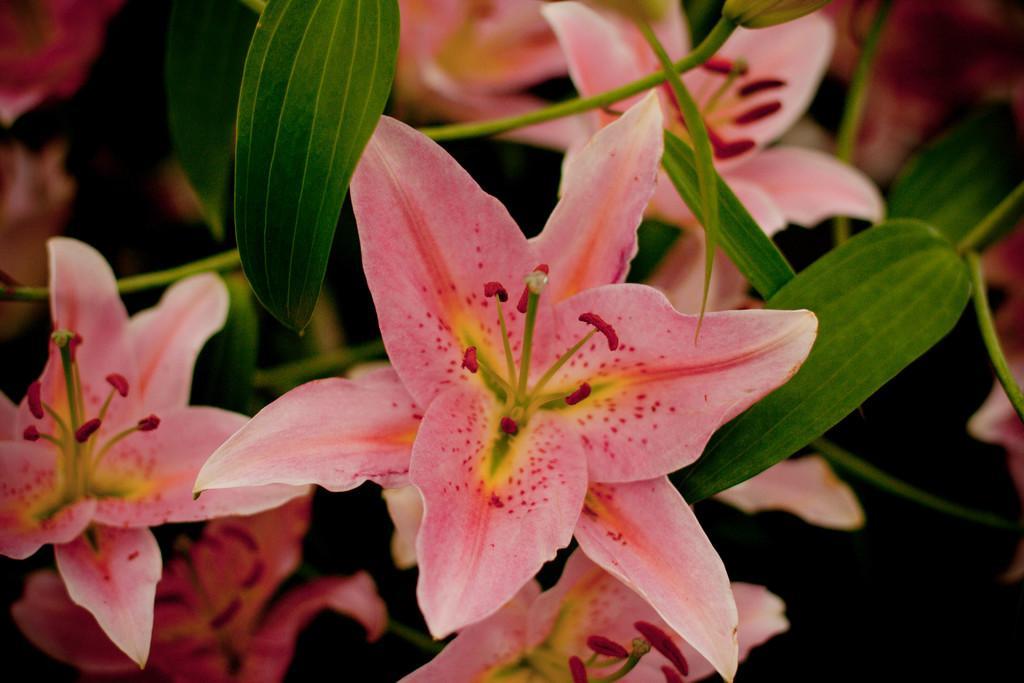Could you give a brief overview of what you see in this image? In this picture we can see few flowers and leaves. 